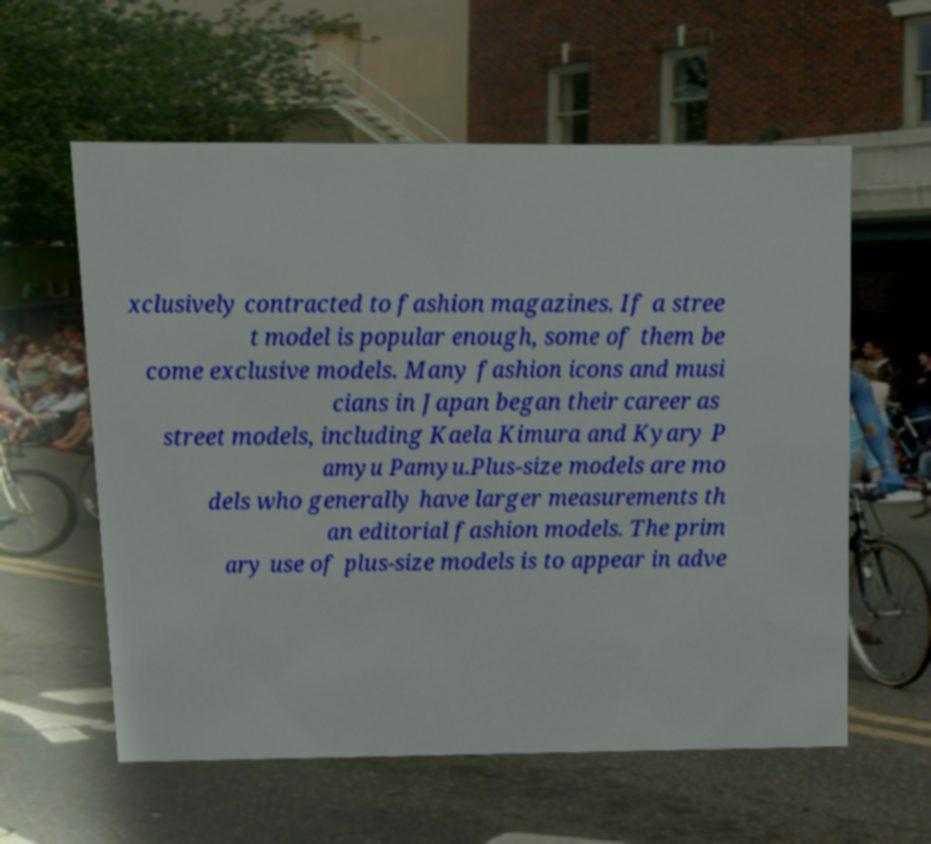Could you assist in decoding the text presented in this image and type it out clearly? xclusively contracted to fashion magazines. If a stree t model is popular enough, some of them be come exclusive models. Many fashion icons and musi cians in Japan began their career as street models, including Kaela Kimura and Kyary P amyu Pamyu.Plus-size models are mo dels who generally have larger measurements th an editorial fashion models. The prim ary use of plus-size models is to appear in adve 